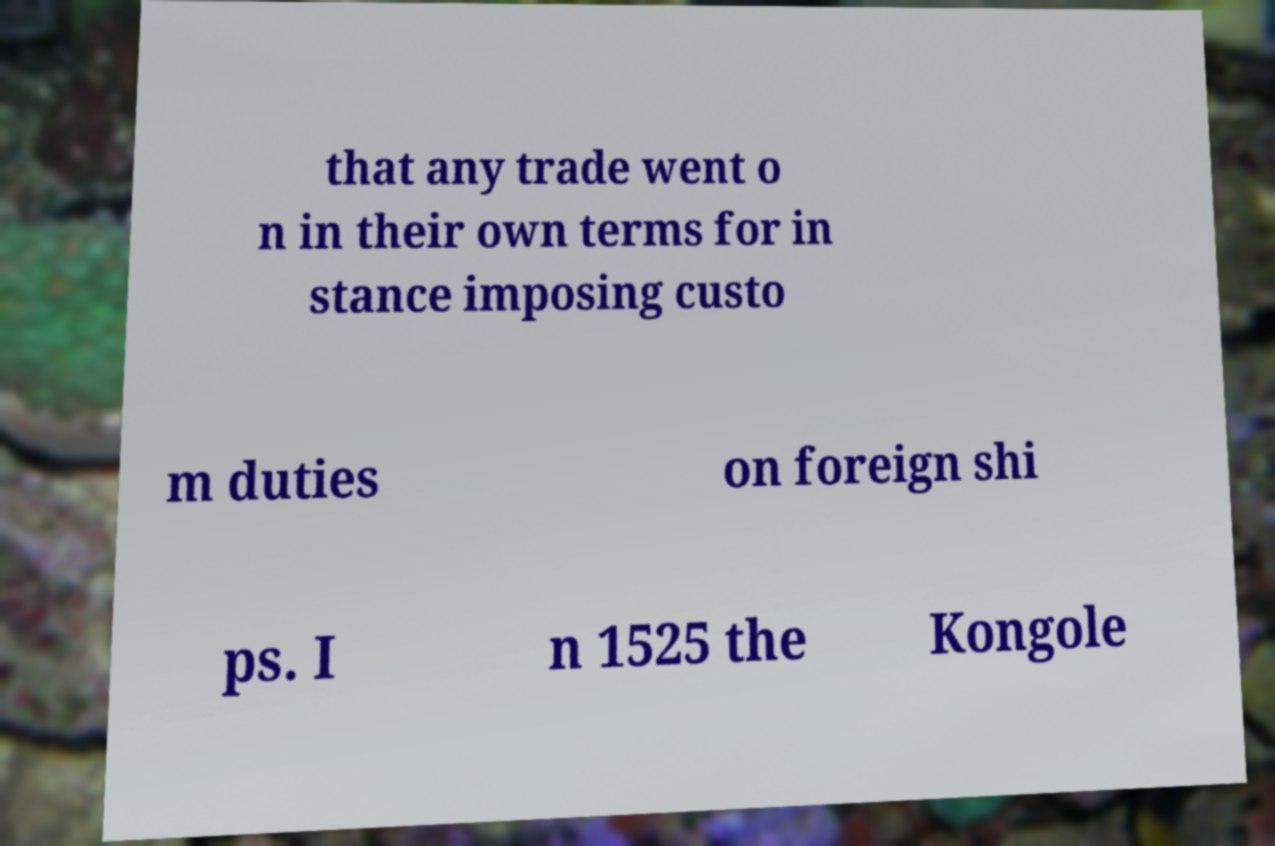Could you assist in decoding the text presented in this image and type it out clearly? that any trade went o n in their own terms for in stance imposing custo m duties on foreign shi ps. I n 1525 the Kongole 